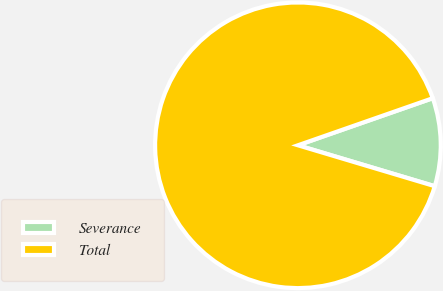<chart> <loc_0><loc_0><loc_500><loc_500><pie_chart><fcel>Severance<fcel>Total<nl><fcel>9.97%<fcel>90.03%<nl></chart> 